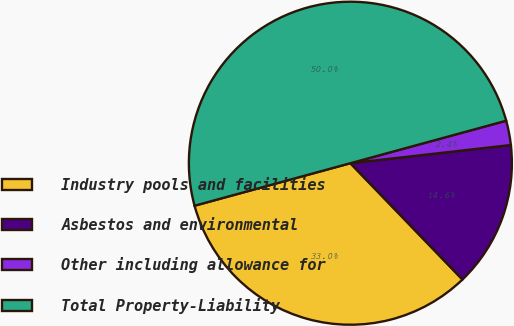<chart> <loc_0><loc_0><loc_500><loc_500><pie_chart><fcel>Industry pools and facilities<fcel>Asbestos and environmental<fcel>Other including allowance for<fcel>Total Property-Liability<nl><fcel>32.97%<fcel>14.59%<fcel>2.44%<fcel>50.0%<nl></chart> 